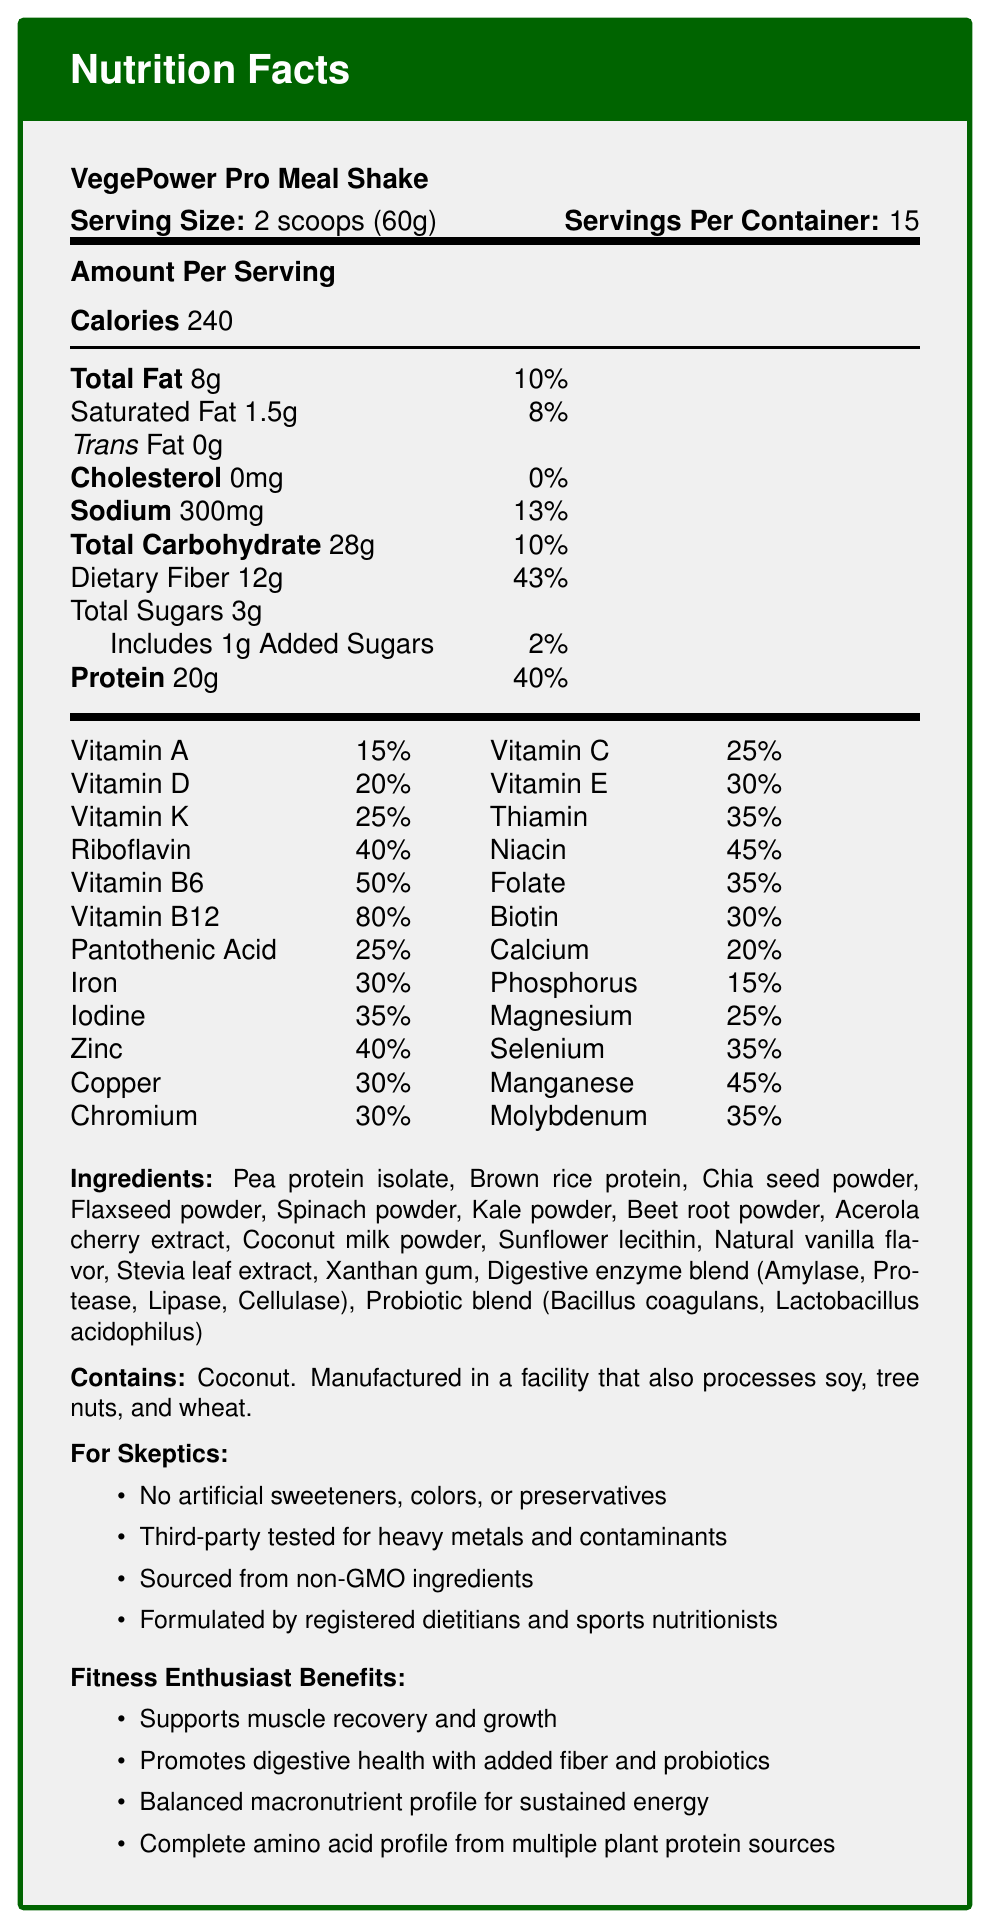How many calories are in a serving of VegePower Pro Meal Shake? The document states "Calories: 240" under the "Amount Per Serving" section.
Answer: 240 How much dietary fiber is in one serving? The "Dietary Fiber" amounts to 12g per serving according to the "Amount Per Serving" section.
Answer: 12g What is the serving size for VegePower Pro Meal Shake? The serving size is explicitly mentioned as "2 scoops (60g)" in the document.
Answer: 2 scoops (60g) How many servings are there per container? The document lists "Servings Per Container: 15".
Answer: 15 What percentage of daily Vitamin B12 does one serving of this product provide? In the Vitamins and Minerals section, the daily value for Vitamin B12 is shown as 80%.
Answer: 80% What is the total amount of protein in one serving of VegePower Pro Meal Shake? The "Amount Per Serving" section lists Protein as 20g.
Answer: 20g Are there any artificial sweeteners, colors, or preservatives in this product? According to the claims, the product contains "No artificial sweeteners, colors, or preservatives."
Answer: No What is the main ingredient of VegePower Pro Meal Shake? A. Coconut milk powder B. Pea protein isolate C. Chia seed powder D. Natural vanilla flavor The ingredient list starts with "Pea protein isolate," indicating it's the main ingredient.
Answer: B. Pea protein isolate What is the daily value percentage of Total Carbohydrates per serving? A. 8% B. 10% C. 13% D. 43% The daily value percentage for Total Carbohydrate is listed as 10%.
Answer: B. 10% Which of the following is NOT an ingredient in VegePower Pro Meal Shake? 1. Spinach powder 2. Flaxseed powder 3. Cane sugar The ingredient list does not include cane sugar.
Answer: 3. Cane sugar Does this product contain any cholesterol? The document specifies "Cholesterol: 0mg", indicating there is no cholesterol in the product.
Answer: No Summarize the primary benefits promoted by VegePower Pro Meal Shake. The document outlines the benefits for fitness enthusiasts, which include muscle support, digestive health, balanced energy, and complete protein sources.
Answer: The shake is designed to support muscle recovery and growth, promote digestive health through added fiber and probiotics, offer balanced macronutrients for sustained energy, and provide a complete amino acid profile from multiple plant protein sources. What is the allergen warning associated with this product? The allergen information highlights the presence of coconut and potential cross-contamination with other allergens.
Answer: Contains coconut. Manufactured in a facility that also processes soy, tree nuts, and wheat. Is this product third-party tested for heavy metals and contaminants? The document states one of the claims for skeptics as "Third-party tested for heavy metals and contaminants."
Answer: Yes What types of enzymes are included in the digestive enzyme blend? The document lists the types of enzymes in the digestive enzyme blend.
Answer: Amylase, Protease, Lipase, Cellulase What is the exact amount of sodium per serving? The document mentions “Sodium: 300mg” under the "Amount Per Serving" section.
Answer: 300mg How many grams of total sugars are in a serving of VegePower Pro Meal Shake? The document lists "Total Sugars: 3g" under the "Amount Per Serving."
Answer: 3g What is the primary protein source in this product? The first ingredient listed is "Pea protein isolate," indicating it's the primary protein source.
Answer: Pea protein isolate Who formulated VegePower Pro Meal Shake? According to the product claims, it was "Formulated by registered dietitians and sports nutritionists."
Answer: Registered dietitians and sports nutritionists Is this product free from genetically modified organisms (GMO)? The document claims the product is "Sourced from non-GMO ingredients."
Answer: Yes What is the total fat content per serving of this shake? The "Amount Per Serving" section shows "Total Fat: 8g."
Answer: 8g Can you tell me the exact amyloid protein content in this product? The document does not provide information about amyloid protein content.
Answer: Not enough information What percentage of daily iron is supplied by a single serving of this shake? The daily value percentage for Iron is listed as 30% in the Vitamins and Minerals section.
Answer: 30% 